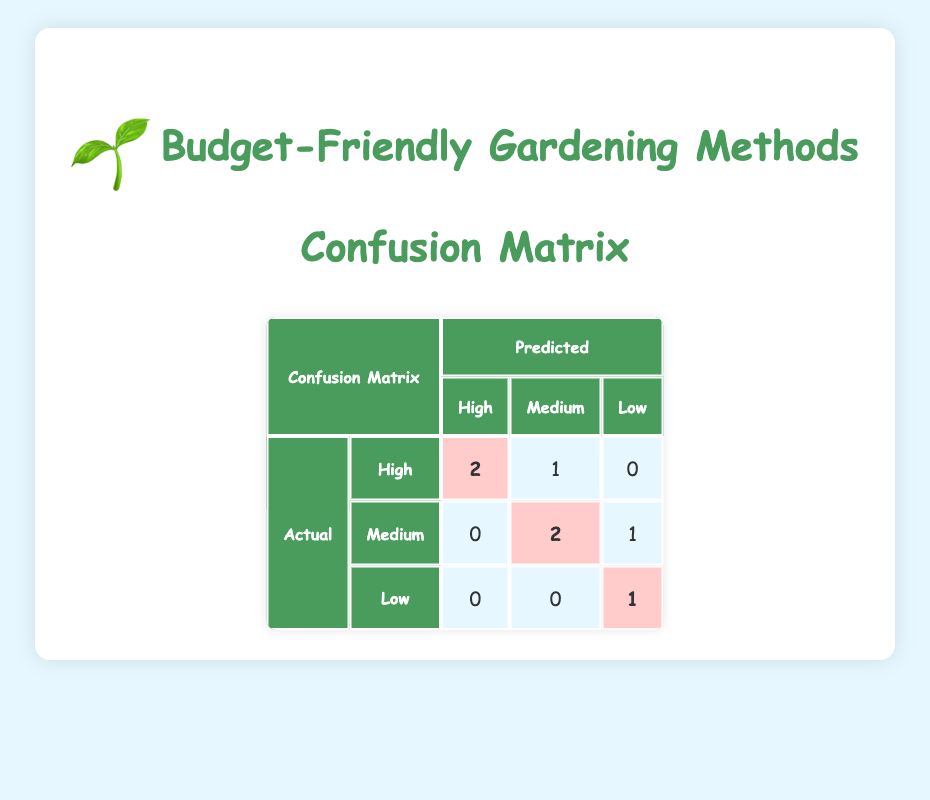What is the predicted actual yield for methods with high success rate? The confusion matrix shows that the predicted yield for high success rate methods is represented in the 'High' column under predicted. The values indicate that out of the total predicted high success rate yields, 2 matched the actual 'High' success rate.
Answer: 2 How many methods were actually predicted as having a medium success rate? To find this, we look at the 'Medium' row under the actual values in the confusion matrix. The value here indicates that 2 methods were actually predicted as having a medium success rate.
Answer: 2 Is there a method that has both low cost and a high success rate? From the gardening methods list, we can see that both 'Raised Bed Gardening' and 'Square Foot Gardening' have low cost and are classified as having a high success rate.
Answer: Yes What is the difference in predicted high success rate methods versus actual high success rate methods? Looking at the confusion matrix, the predicted high success rate methods are 2 while the actual high success rate is 3. The difference is calculated by subtracting the predicted value from the actual: 3 - 2 = 1.
Answer: 1 How many total gardening methods have a low success rate? Referring to the gardening methods list, only 'Traditional Row Gardening' is categorized under low success rate. Thus, the total methods with low success rate is 1.
Answer: 1 What is the average yield of the methods classified as having medium success rates? The yield for both 'Container Gardening' and 'Vertical Gardening' is considered as medium success rates (10 kg and 9 kg respectively). We find the average by adding their yields: (10 + 9) / 2 = 9.5 kg.
Answer: 9.5 kg Which success rate category has the highest number of actual methods? By examining the actual values in the confusion matrix, we find there are 3 methods in the 'High' category, which is higher than both 'Medium' and 'Low' categories, indicating this category has the most methods.
Answer: High If we consolidate the actual high and medium success rates, how many methods are there in total? From the confusion matrix, there are 3 methods with actual high success rates and 3 with actual medium success rates. Summing these gives us a total of 3 + 3 = 6 methods.
Answer: 6 How many methods have both medium success and medium cost? Referring to the gardening methods list, both 'Container Gardening' and 'Vertical Gardening' feature medium success rate and medium cost. So, there are 2 methods in total.
Answer: 2 